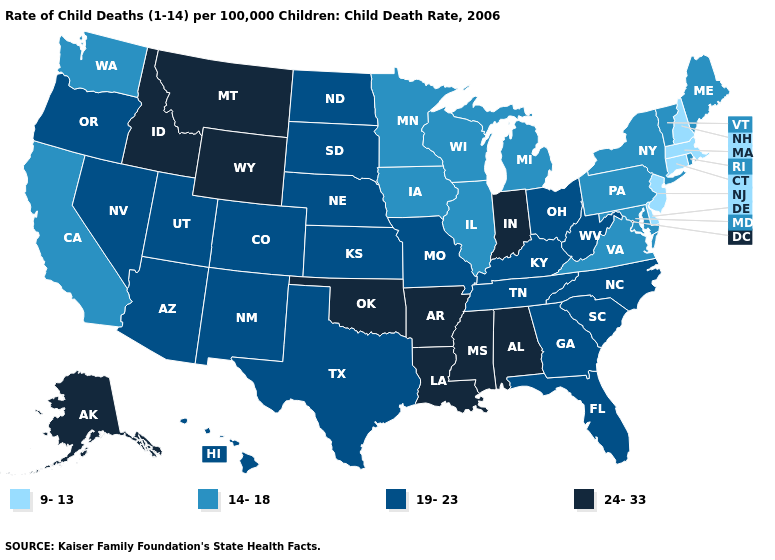Name the states that have a value in the range 9-13?
Write a very short answer. Connecticut, Delaware, Massachusetts, New Hampshire, New Jersey. Which states hav the highest value in the West?
Quick response, please. Alaska, Idaho, Montana, Wyoming. Among the states that border North Dakota , which have the highest value?
Concise answer only. Montana. What is the value of Indiana?
Short answer required. 24-33. What is the value of Missouri?
Give a very brief answer. 19-23. What is the highest value in states that border Oklahoma?
Write a very short answer. 24-33. What is the value of Texas?
Answer briefly. 19-23. Among the states that border Maryland , which have the highest value?
Short answer required. West Virginia. Name the states that have a value in the range 14-18?
Short answer required. California, Illinois, Iowa, Maine, Maryland, Michigan, Minnesota, New York, Pennsylvania, Rhode Island, Vermont, Virginia, Washington, Wisconsin. Does Delaware have the lowest value in the South?
Answer briefly. Yes. Name the states that have a value in the range 9-13?
Concise answer only. Connecticut, Delaware, Massachusetts, New Hampshire, New Jersey. Does the first symbol in the legend represent the smallest category?
Give a very brief answer. Yes. Does Kentucky have the same value as Washington?
Concise answer only. No. Does New Mexico have a higher value than New Hampshire?
Answer briefly. Yes. What is the highest value in states that border Texas?
Concise answer only. 24-33. 